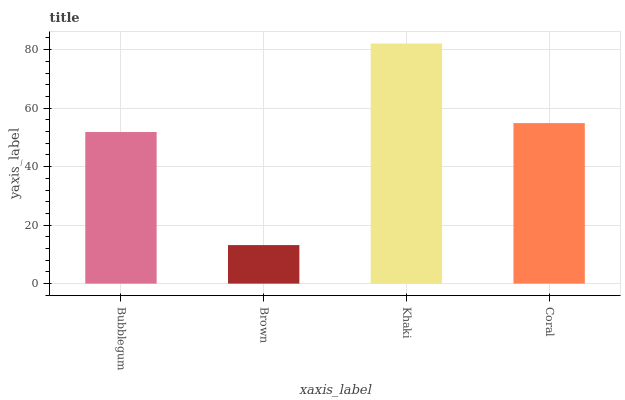Is Brown the minimum?
Answer yes or no. Yes. Is Khaki the maximum?
Answer yes or no. Yes. Is Khaki the minimum?
Answer yes or no. No. Is Brown the maximum?
Answer yes or no. No. Is Khaki greater than Brown?
Answer yes or no. Yes. Is Brown less than Khaki?
Answer yes or no. Yes. Is Brown greater than Khaki?
Answer yes or no. No. Is Khaki less than Brown?
Answer yes or no. No. Is Coral the high median?
Answer yes or no. Yes. Is Bubblegum the low median?
Answer yes or no. Yes. Is Bubblegum the high median?
Answer yes or no. No. Is Khaki the low median?
Answer yes or no. No. 